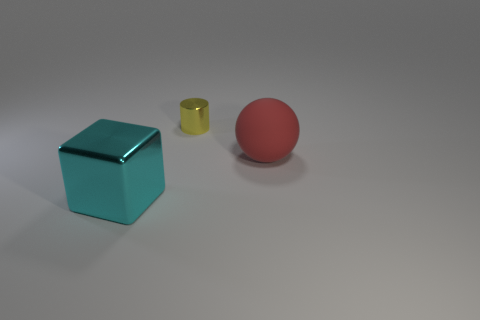Add 3 yellow shiny things. How many objects exist? 6 Subtract all cylinders. How many objects are left? 2 Subtract 0 yellow blocks. How many objects are left? 3 Subtract all cyan balls. Subtract all big blocks. How many objects are left? 2 Add 1 big rubber objects. How many big rubber objects are left? 2 Add 2 small matte cylinders. How many small matte cylinders exist? 2 